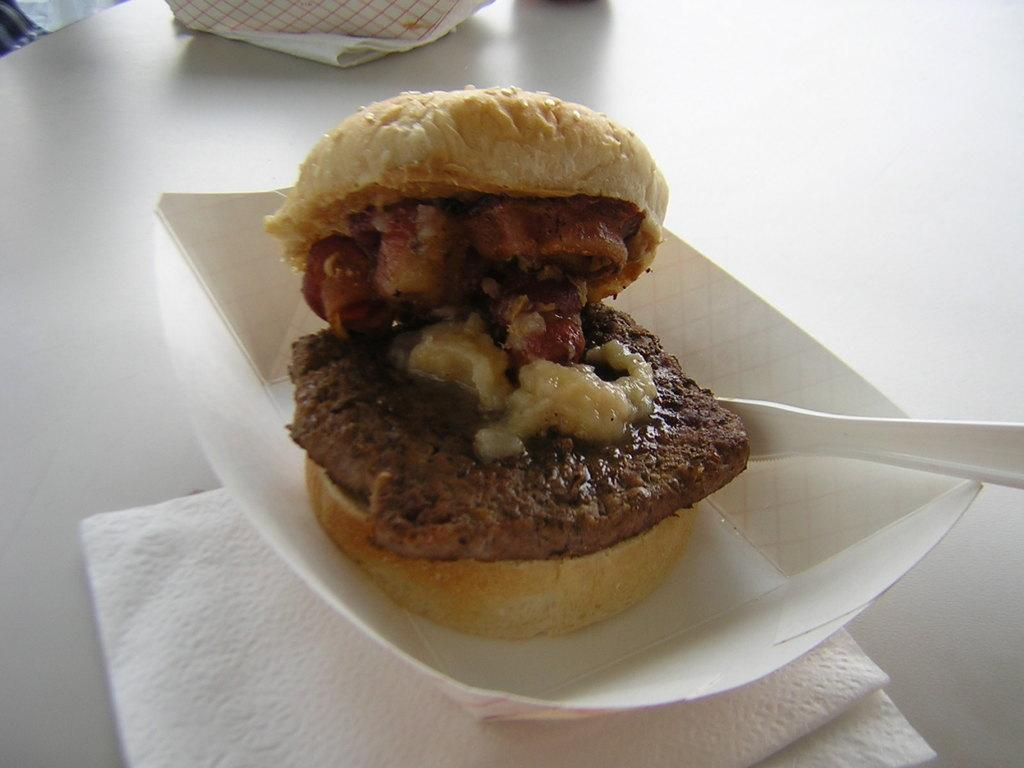What type of food item is visible in the image? The specific type of food item is not mentioned, but there is a food item in the image. What utensil is present in the image? There is a spoon in the image. What type of containers can be seen in the image? There are boxes in the image. What can be used for cleaning or wiping in the image? Tissue papers are present in the image for cleaning or wiping. Where are all these items located? All of these items are on a table. Is there a power outlet visible in the image? There is no mention of a power outlet in the provided facts, so we cannot determine if one is present in the image. Can you tell me how many cables are connected to the bed in the image? There is no bed or cable mentioned in the provided facts, so we cannot determine if they are present in the image. 